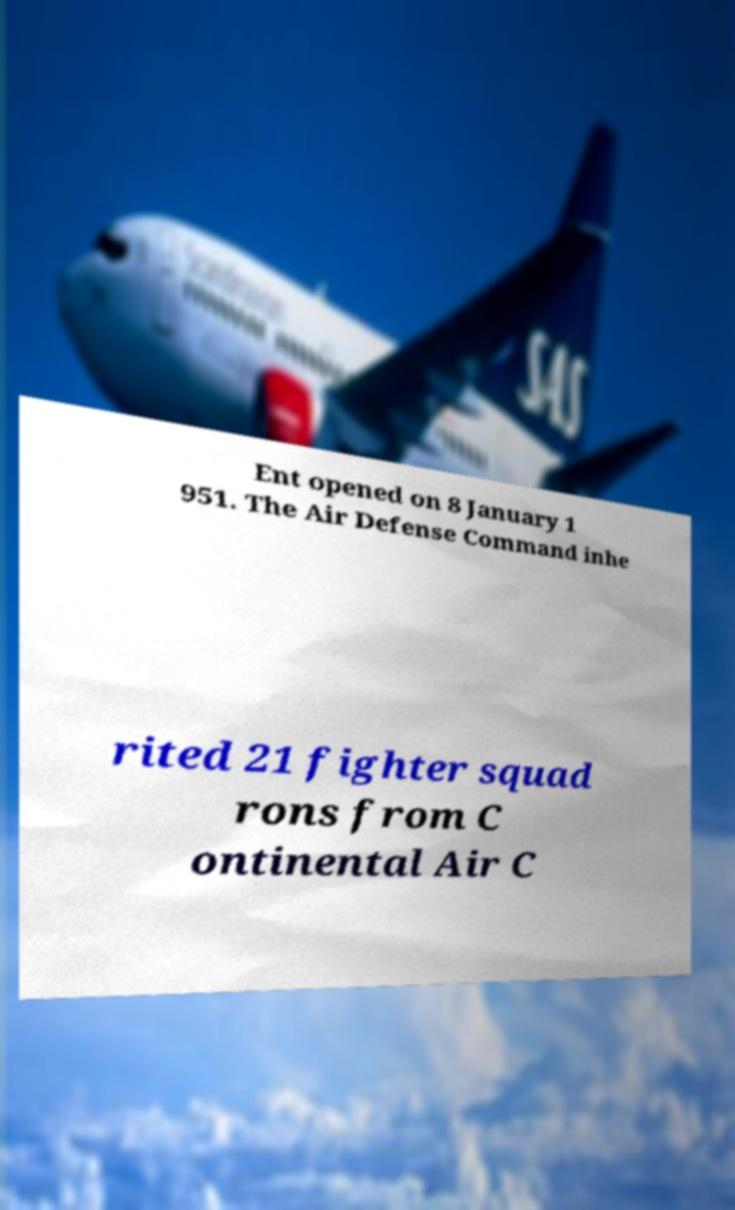Please identify and transcribe the text found in this image. Ent opened on 8 January 1 951. The Air Defense Command inhe rited 21 fighter squad rons from C ontinental Air C 